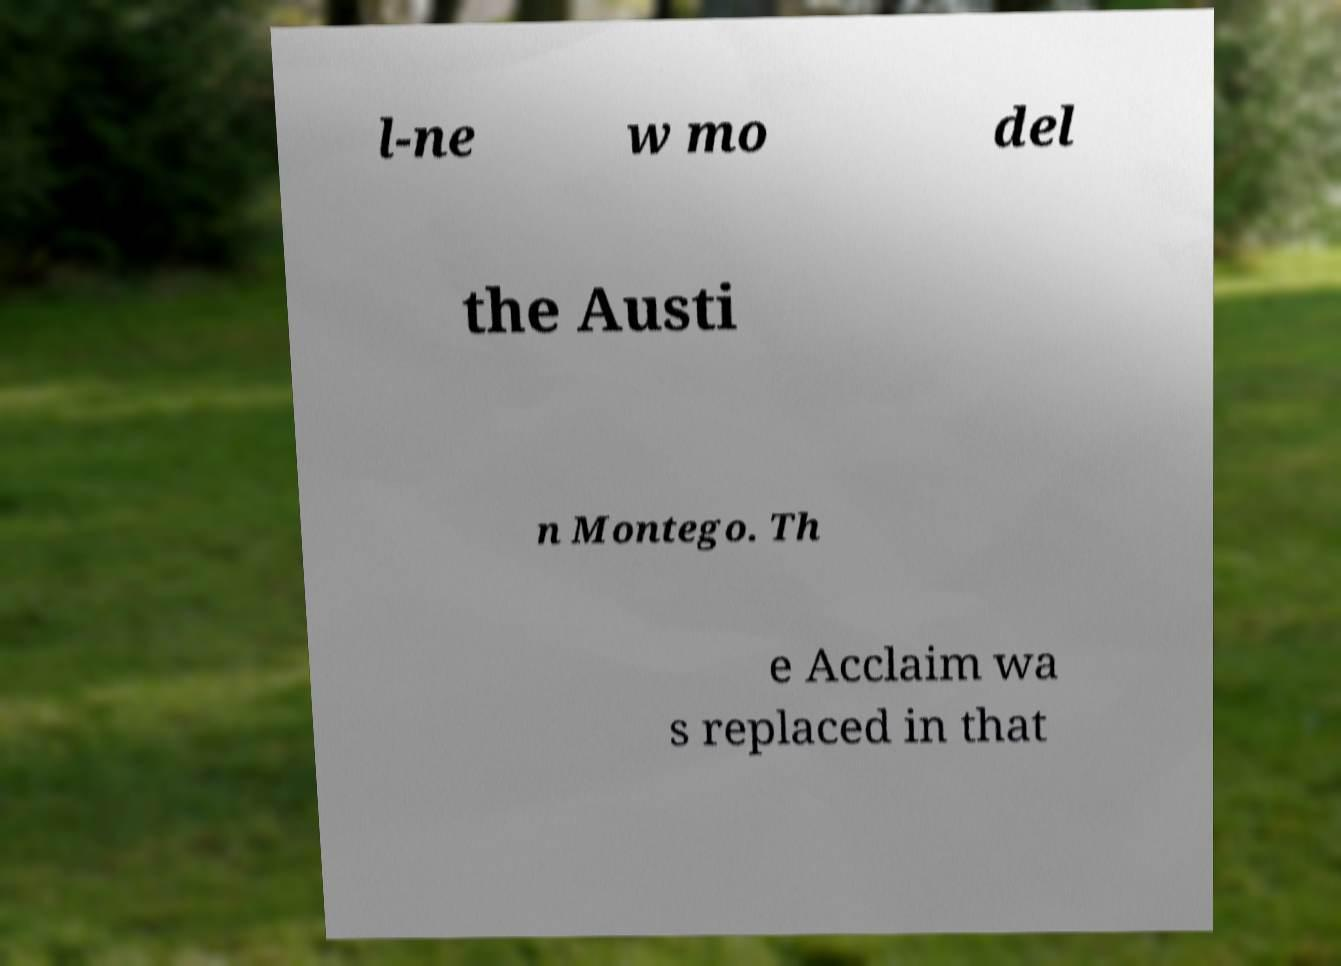Can you accurately transcribe the text from the provided image for me? l-ne w mo del the Austi n Montego. Th e Acclaim wa s replaced in that 